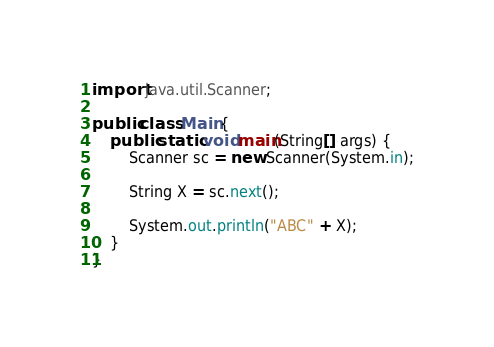Convert code to text. <code><loc_0><loc_0><loc_500><loc_500><_Java_>import java.util.Scanner;

public class Main {
	public static void main(String[] args) {
		Scanner sc = new Scanner(System.in);

		String X = sc.next();

		System.out.println("ABC" + X);
	}
}
</code> 